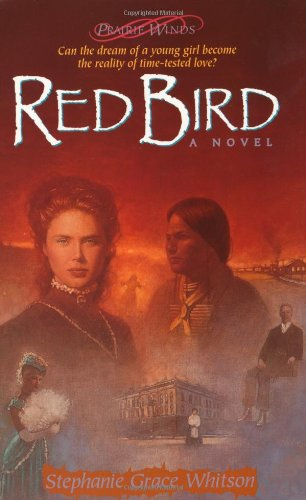Can you describe a central theme in 'Red Bird'? A central theme in 'Red Bird' is the exploration of time-tested love, examining how relationships and personal values evolve amidst the hardships of frontier life. 